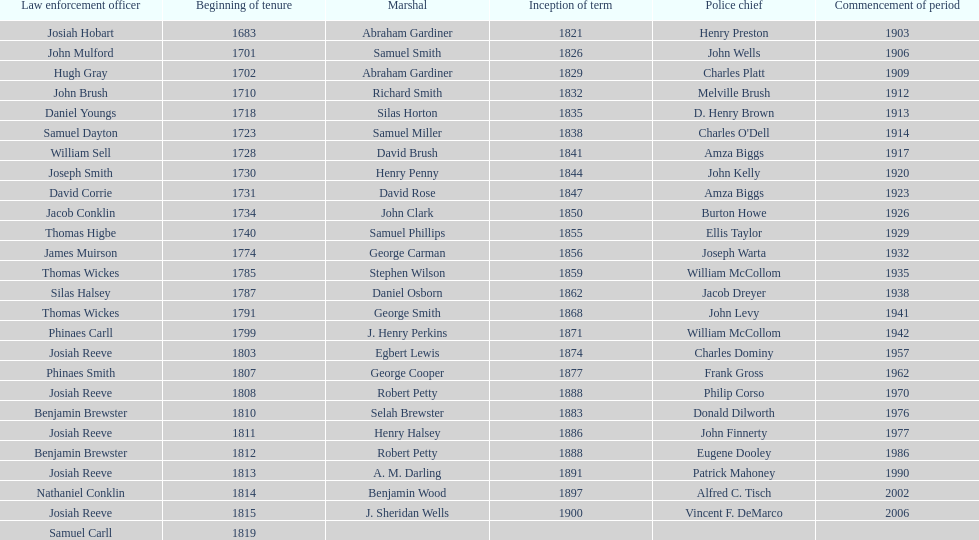What is the total number of sheriffs that were in office in suffolk county between 1903 and 1957? 17. 